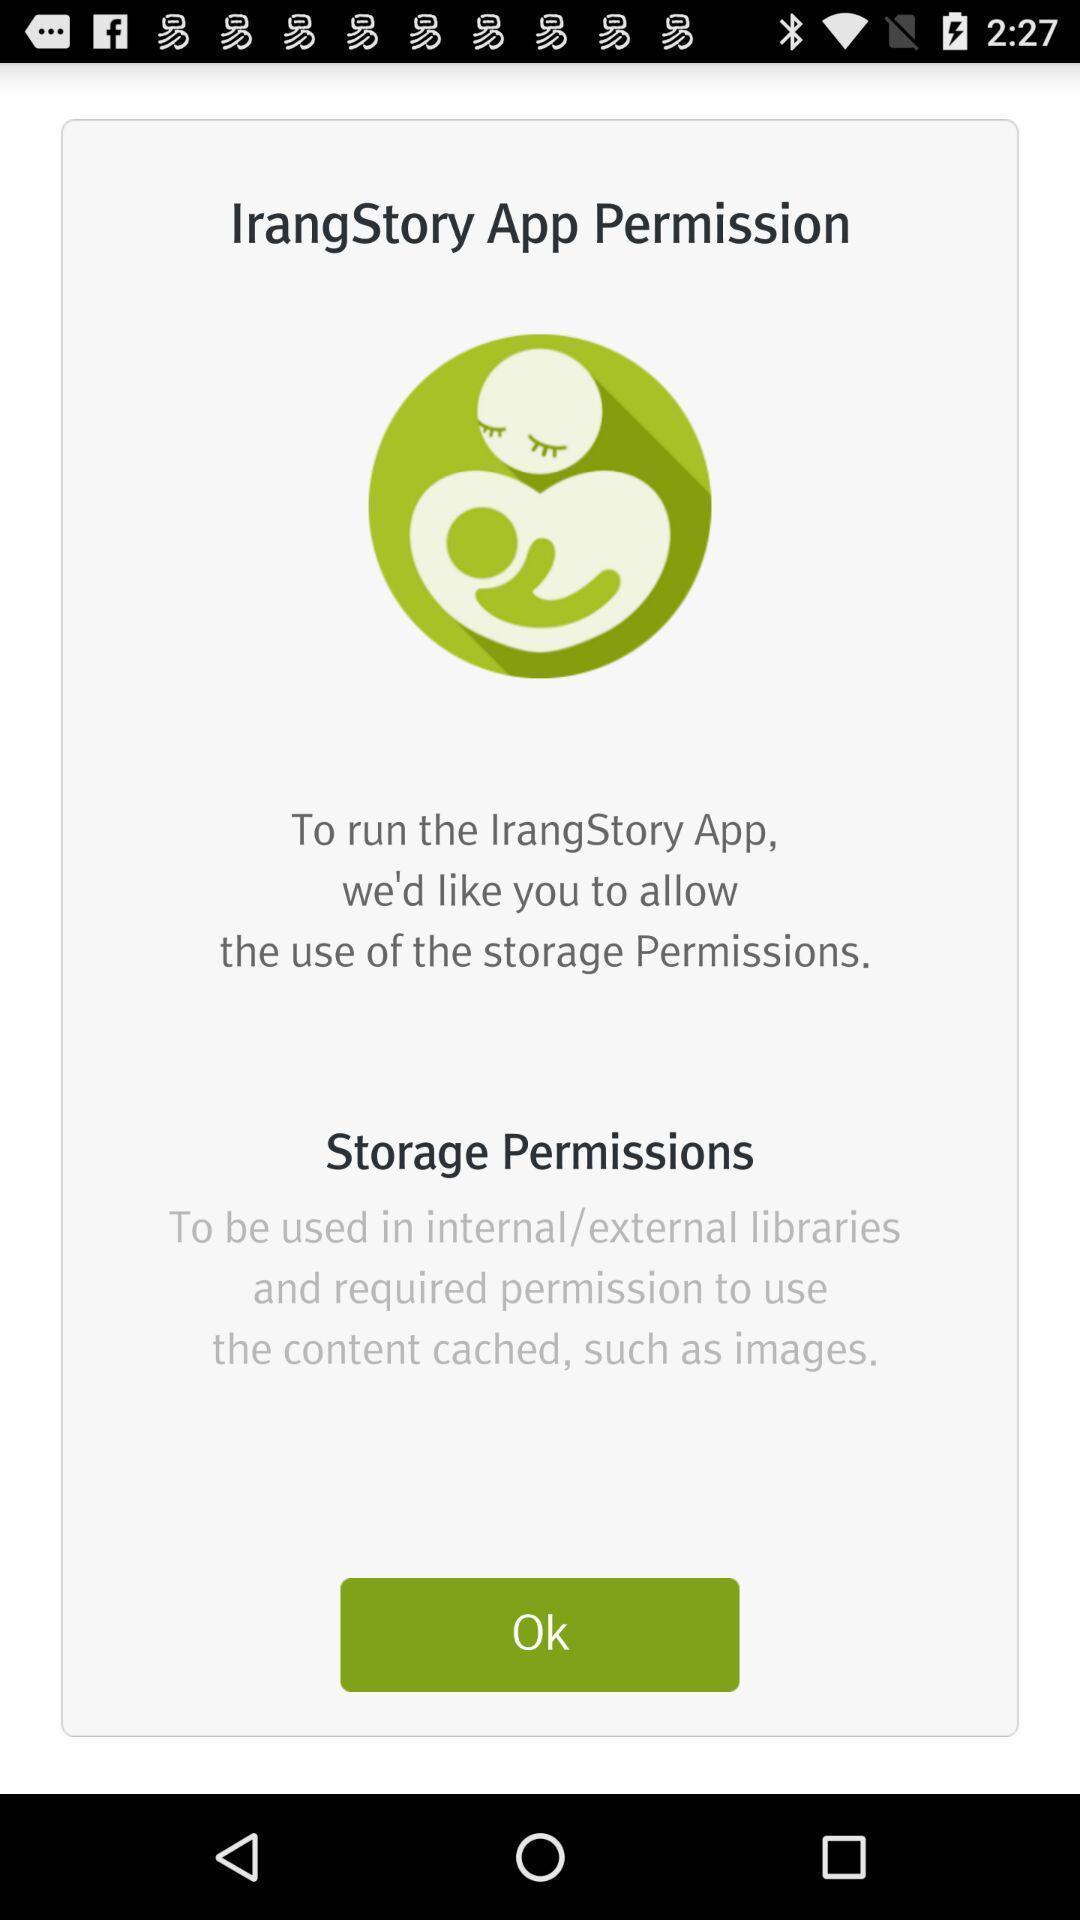Describe the content in this image. Storage permissions in app permission. 